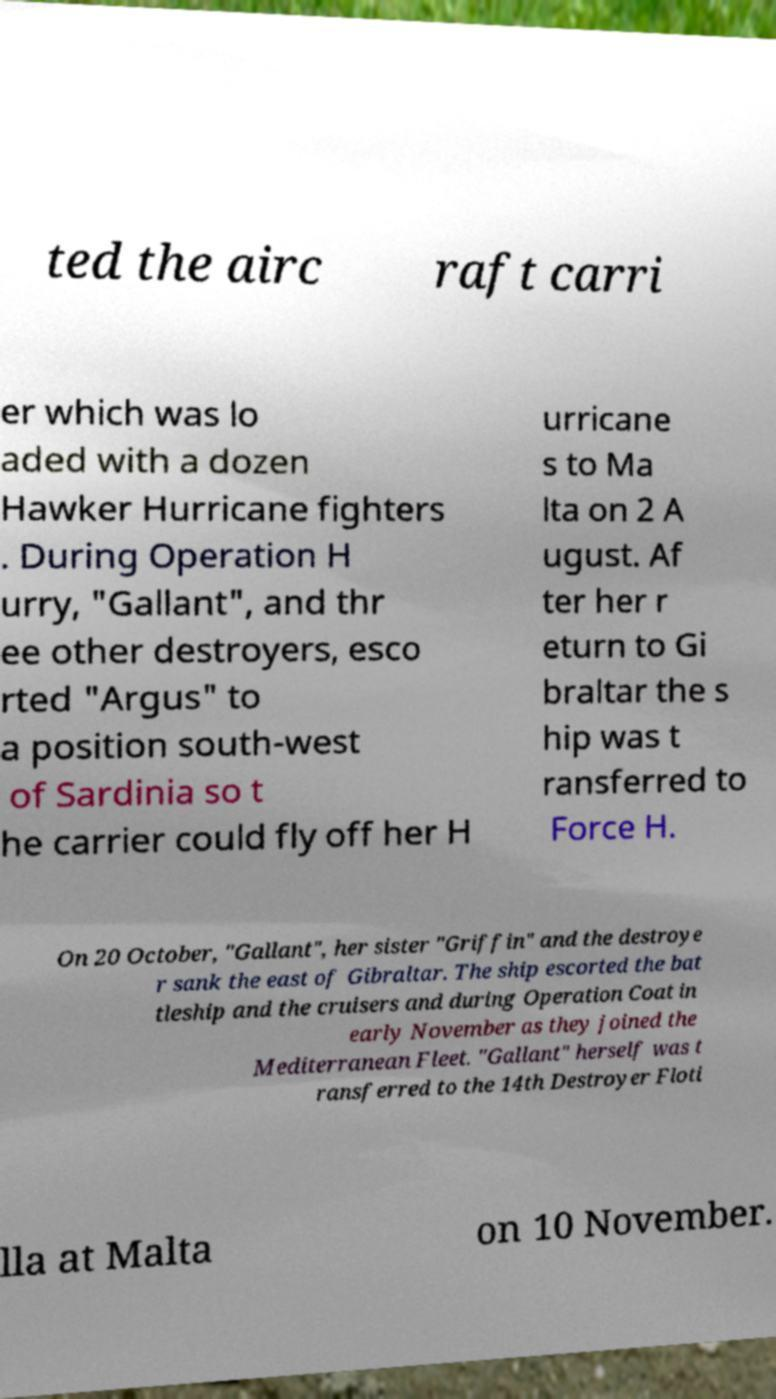Could you assist in decoding the text presented in this image and type it out clearly? ted the airc raft carri er which was lo aded with a dozen Hawker Hurricane fighters . During Operation H urry, "Gallant", and thr ee other destroyers, esco rted "Argus" to a position south-west of Sardinia so t he carrier could fly off her H urricane s to Ma lta on 2 A ugust. Af ter her r eturn to Gi braltar the s hip was t ransferred to Force H. On 20 October, "Gallant", her sister "Griffin" and the destroye r sank the east of Gibraltar. The ship escorted the bat tleship and the cruisers and during Operation Coat in early November as they joined the Mediterranean Fleet. "Gallant" herself was t ransferred to the 14th Destroyer Floti lla at Malta on 10 November. 